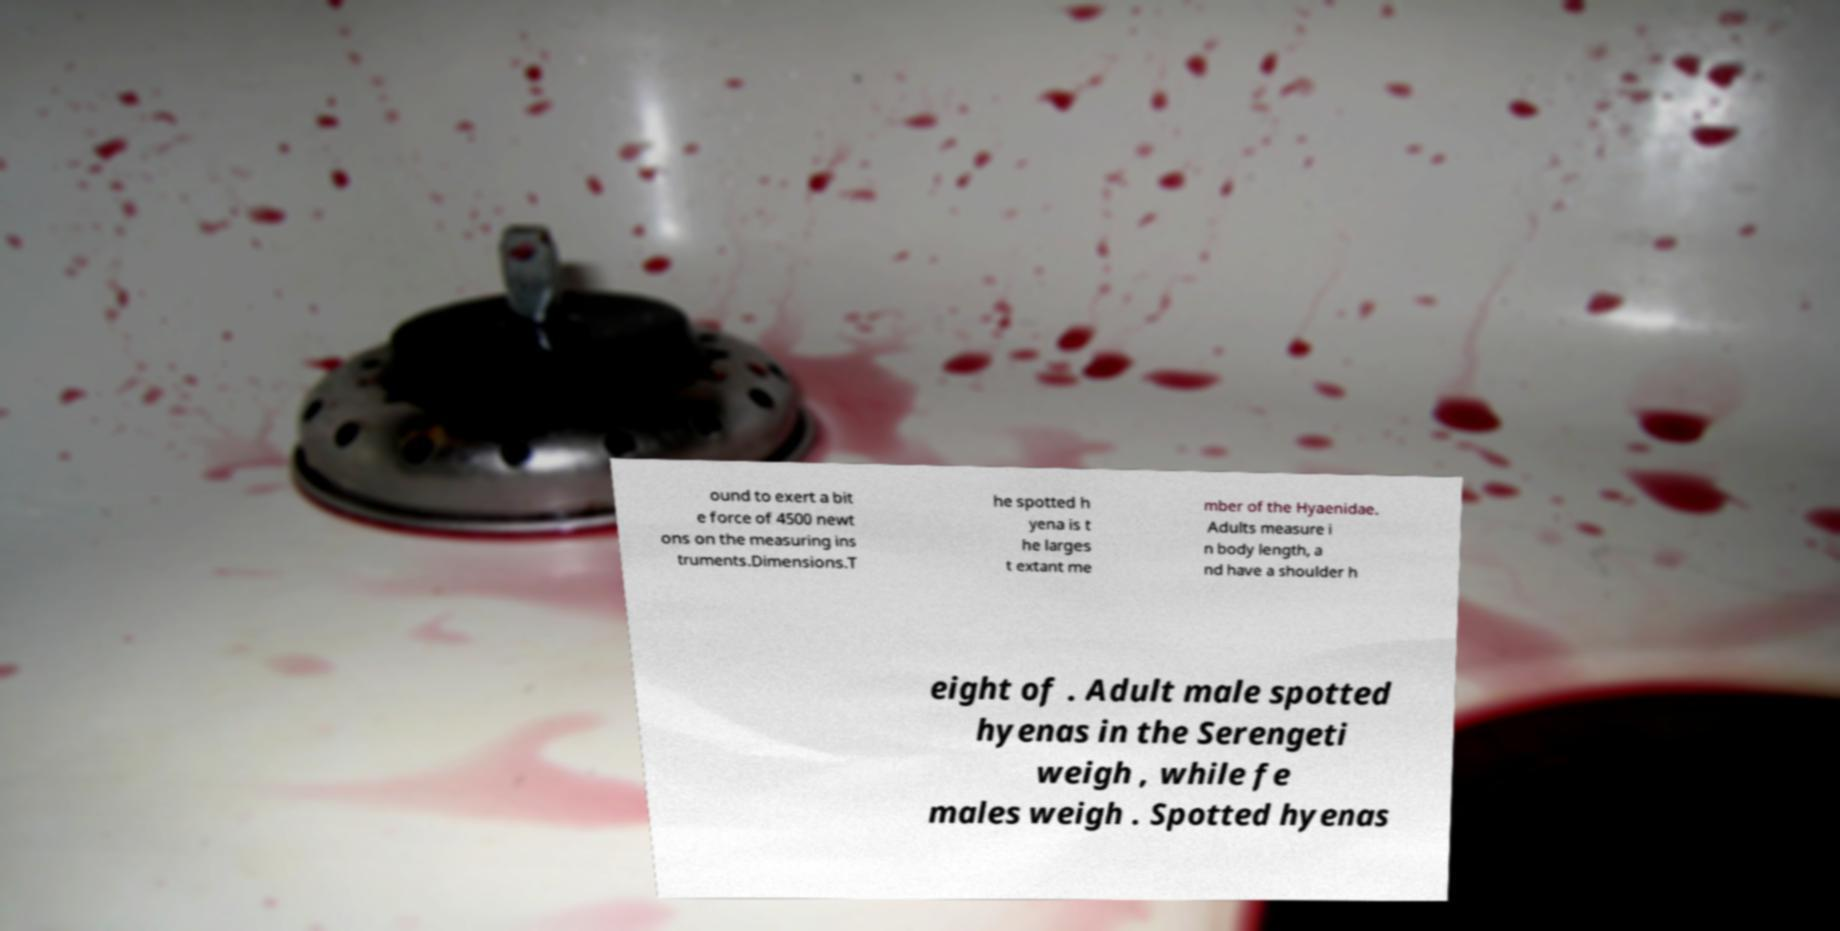Please read and relay the text visible in this image. What does it say? ound to exert a bit e force of 4500 newt ons on the measuring ins truments.Dimensions.T he spotted h yena is t he larges t extant me mber of the Hyaenidae. Adults measure i n body length, a nd have a shoulder h eight of . Adult male spotted hyenas in the Serengeti weigh , while fe males weigh . Spotted hyenas 